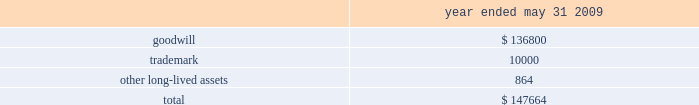The following details the impairment charge resulting from our review ( in thousands ) : .
Net income attributable to noncontrolling interests , net of tax noncontrolling interest , net of tax increased $ 28.9 million from $ 8.1 million fiscal 2008 .
The increase was primarily related to our acquisition of a 51% ( 51 % ) majority interest in hsbc merchant services , llp on june 30 , net income attributable to global payments and diluted earnings per share during fiscal 2009 we reported net income of $ 37.2 million ( $ 0.46 diluted earnings per share ) .
Liquidity and capital resources a significant portion of our liquidity comes from operating cash flows , which are generally sufficient to fund operations , planned capital expenditures , debt service and various strategic investments in our business .
Cash flow from operations is used to make planned capital investments in our business , to pursue acquisitions that meet our corporate objectives , to pay dividends , and to pay off debt and repurchase our shares at the discretion of our board of directors .
Accumulated cash balances are invested in high-quality and marketable short term instruments .
Our capital plan objectives are to support the company 2019s operational needs and strategic plan for long term growth while maintaining a low cost of capital .
Lines of credit are used in certain of our markets to fund settlement and as a source of working capital and , along with other bank financing , to fund acquisitions .
We regularly evaluate our liquidity and capital position relative to cash requirements , and we may elect to raise additional funds in the future , either through the issuance of debt , equity or otherwise .
At may 31 , 2010 , we had cash and cash equivalents totaling $ 769.9 million .
Of this amount , we consider $ 268.1 million to be available cash , which generally excludes settlement related and merchant reserve cash balances .
Settlement related cash balances represent surplus funds that we hold on behalf of our member sponsors when the incoming amount from the card networks precedes the member sponsors 2019 funding obligation to the merchant .
Merchant reserve cash balances represent funds collected from our merchants that serve as collateral ( 201cmerchant reserves 201d ) to minimize contingent liabilities associated with any losses that may occur under the merchant agreement .
At may 31 , 2010 , our cash and cash equivalents included $ 199.4 million related to merchant reserves .
While this cash is not restricted in its use , we believe that designating this cash to collateralize merchant reserves strengthens our fiduciary standing with our member sponsors and is in accordance with the guidelines set by the card networks .
See cash and cash equivalents and settlement processing assets and obligations under note 1 in the notes to the consolidated financial statements for additional details .
Net cash provided by operating activities increased $ 82.8 million to $ 465.8 million for fiscal 2010 from the prior year .
Income from continuing operations increased $ 16.0 million and we had cash provided by changes in working capital of $ 60.2 million .
The working capital change was primarily due to the change in net settlement processing assets and obligations of $ 80.3 million and the change in accounts receivable of $ 13.4 million , partially offset by the change .
What is the percentage growth in net cash provided by operating activities from 2009 to 2010? 
Computations: (82.8 / (465.8 - 82.8))
Answer: 0.21619. 